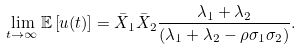Convert formula to latex. <formula><loc_0><loc_0><loc_500><loc_500>\lim _ { t \rightarrow \infty } \mathbb { E } \left [ u ( t ) \right ] = \bar { X } _ { 1 } \bar { X } _ { 2 } \frac { \lambda _ { 1 } + \lambda _ { 2 } } { \left ( \lambda _ { 1 } + \lambda _ { 2 } - \rho \sigma _ { 1 } \sigma _ { 2 } \right ) } .</formula> 